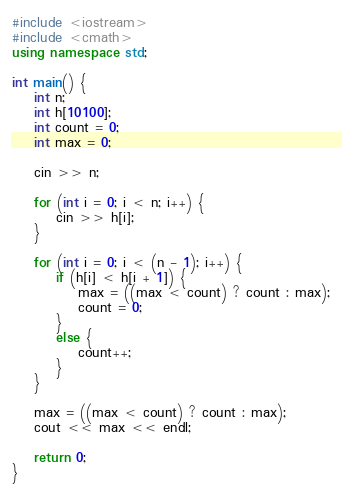<code> <loc_0><loc_0><loc_500><loc_500><_C++_>#include <iostream>
#include <cmath>
using namespace std;

int main() {
    int n;
    int h[10100];
    int count = 0;
    int max = 0;

    cin >> n;

    for (int i = 0; i < n; i++) {
        cin >> h[i];
    }

    for (int i = 0; i < (n - 1); i++) {
        if (h[i] < h[i + 1]) {
            max = ((max < count) ? count : max);
            count = 0;
        }
        else {
            count++;
        }
    }

    max = ((max < count) ? count : max);
    cout << max << endl;

    return 0;
}</code> 